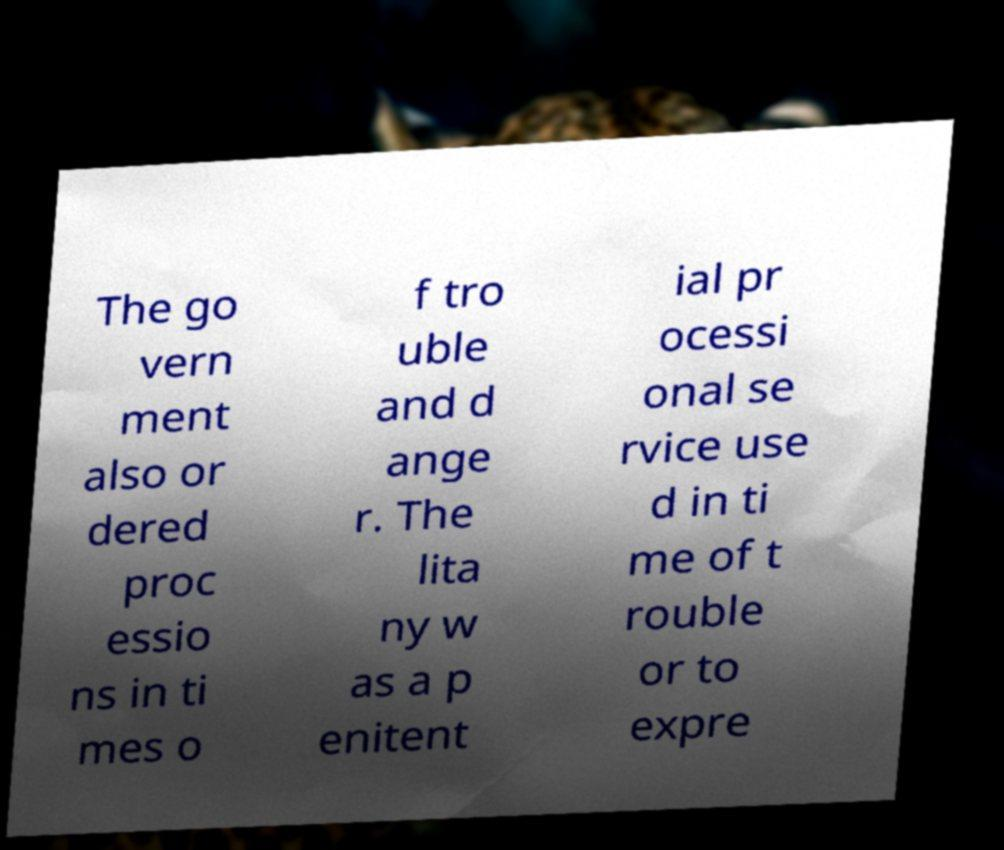For documentation purposes, I need the text within this image transcribed. Could you provide that? The go vern ment also or dered proc essio ns in ti mes o f tro uble and d ange r. The lita ny w as a p enitent ial pr ocessi onal se rvice use d in ti me of t rouble or to expre 